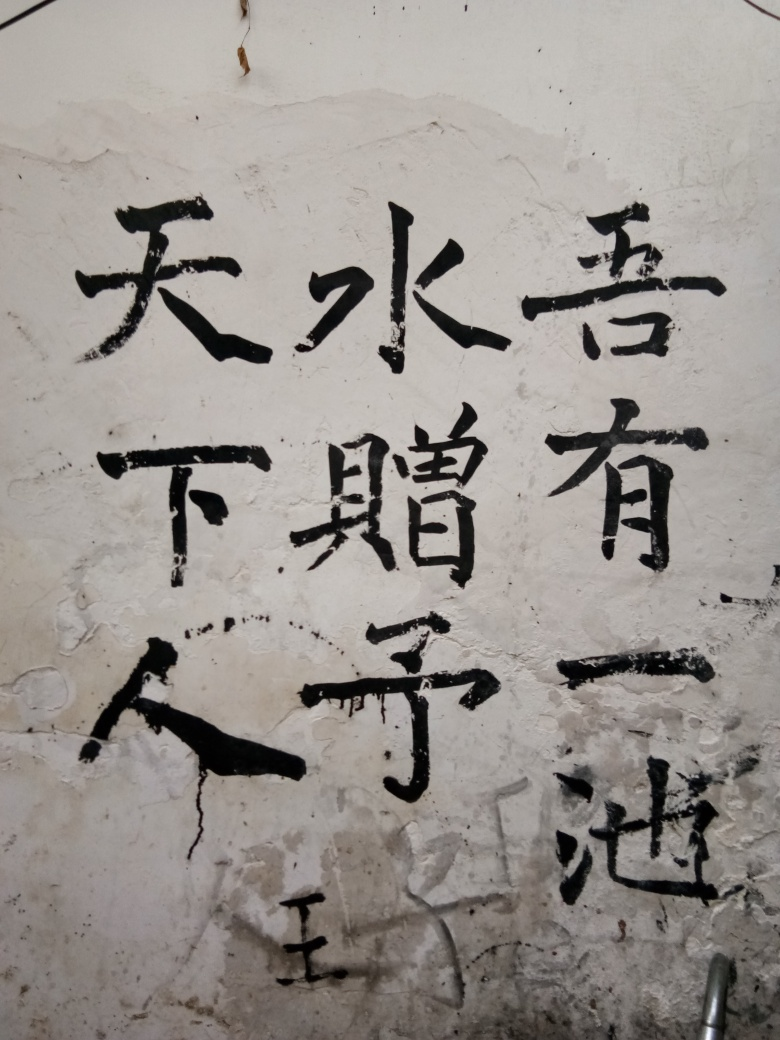What can you tell me about the texture and condition of the surface shown? The surface appears to be an aged wall with patches of plaster peeling off, giving it a rugged texture. There are visible cracks and crevices, indicating wear and exposure to elements over time. The varying degrees of erosion and chipping paint suggest a history and prolonged use of the surface, contributing to its character. 